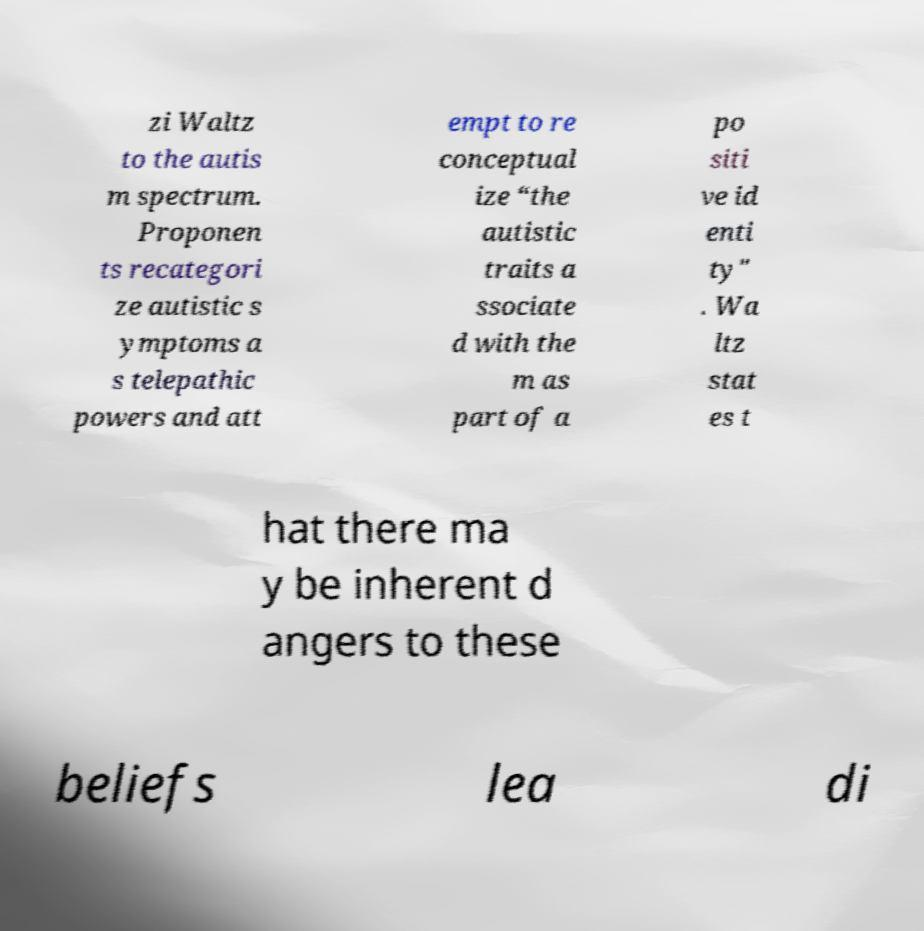I need the written content from this picture converted into text. Can you do that? zi Waltz to the autis m spectrum. Proponen ts recategori ze autistic s ymptoms a s telepathic powers and att empt to re conceptual ize “the autistic traits a ssociate d with the m as part of a po siti ve id enti ty" . Wa ltz stat es t hat there ma y be inherent d angers to these beliefs lea di 